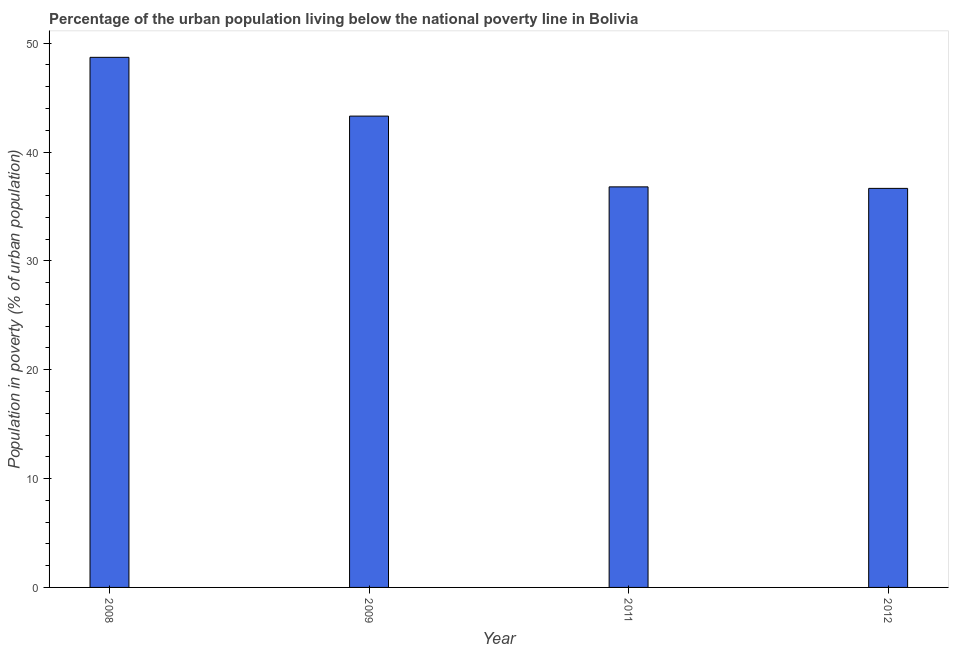Does the graph contain any zero values?
Offer a terse response. No. What is the title of the graph?
Provide a short and direct response. Percentage of the urban population living below the national poverty line in Bolivia. What is the label or title of the Y-axis?
Offer a very short reply. Population in poverty (% of urban population). What is the percentage of urban population living below poverty line in 2009?
Offer a terse response. 43.3. Across all years, what is the maximum percentage of urban population living below poverty line?
Your answer should be very brief. 48.7. Across all years, what is the minimum percentage of urban population living below poverty line?
Offer a very short reply. 36.66. In which year was the percentage of urban population living below poverty line minimum?
Your answer should be very brief. 2012. What is the sum of the percentage of urban population living below poverty line?
Keep it short and to the point. 165.46. What is the difference between the percentage of urban population living below poverty line in 2011 and 2012?
Ensure brevity in your answer.  0.14. What is the average percentage of urban population living below poverty line per year?
Your answer should be compact. 41.37. What is the median percentage of urban population living below poverty line?
Give a very brief answer. 40.05. What is the ratio of the percentage of urban population living below poverty line in 2011 to that in 2012?
Provide a short and direct response. 1. Is the sum of the percentage of urban population living below poverty line in 2008 and 2012 greater than the maximum percentage of urban population living below poverty line across all years?
Your answer should be very brief. Yes. What is the difference between the highest and the lowest percentage of urban population living below poverty line?
Ensure brevity in your answer.  12.04. How many bars are there?
Give a very brief answer. 4. Are all the bars in the graph horizontal?
Make the answer very short. No. What is the Population in poverty (% of urban population) in 2008?
Provide a short and direct response. 48.7. What is the Population in poverty (% of urban population) in 2009?
Provide a short and direct response. 43.3. What is the Population in poverty (% of urban population) of 2011?
Provide a succinct answer. 36.8. What is the Population in poverty (% of urban population) of 2012?
Your response must be concise. 36.66. What is the difference between the Population in poverty (% of urban population) in 2008 and 2011?
Your answer should be compact. 11.9. What is the difference between the Population in poverty (% of urban population) in 2008 and 2012?
Give a very brief answer. 12.04. What is the difference between the Population in poverty (% of urban population) in 2009 and 2012?
Offer a very short reply. 6.64. What is the difference between the Population in poverty (% of urban population) in 2011 and 2012?
Make the answer very short. 0.14. What is the ratio of the Population in poverty (% of urban population) in 2008 to that in 2011?
Offer a terse response. 1.32. What is the ratio of the Population in poverty (% of urban population) in 2008 to that in 2012?
Your answer should be compact. 1.33. What is the ratio of the Population in poverty (% of urban population) in 2009 to that in 2011?
Give a very brief answer. 1.18. What is the ratio of the Population in poverty (% of urban population) in 2009 to that in 2012?
Your answer should be very brief. 1.18. What is the ratio of the Population in poverty (% of urban population) in 2011 to that in 2012?
Your answer should be very brief. 1. 